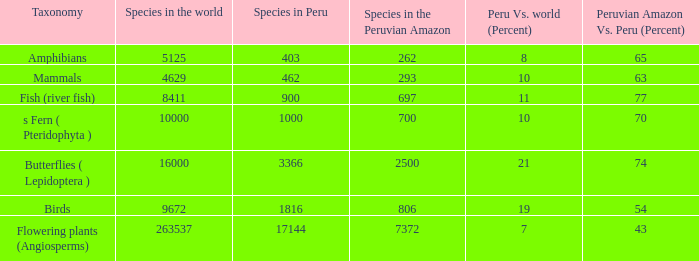What's the minimum species in the peruvian amazon with taxonomy s fern ( pteridophyta ) 700.0. 